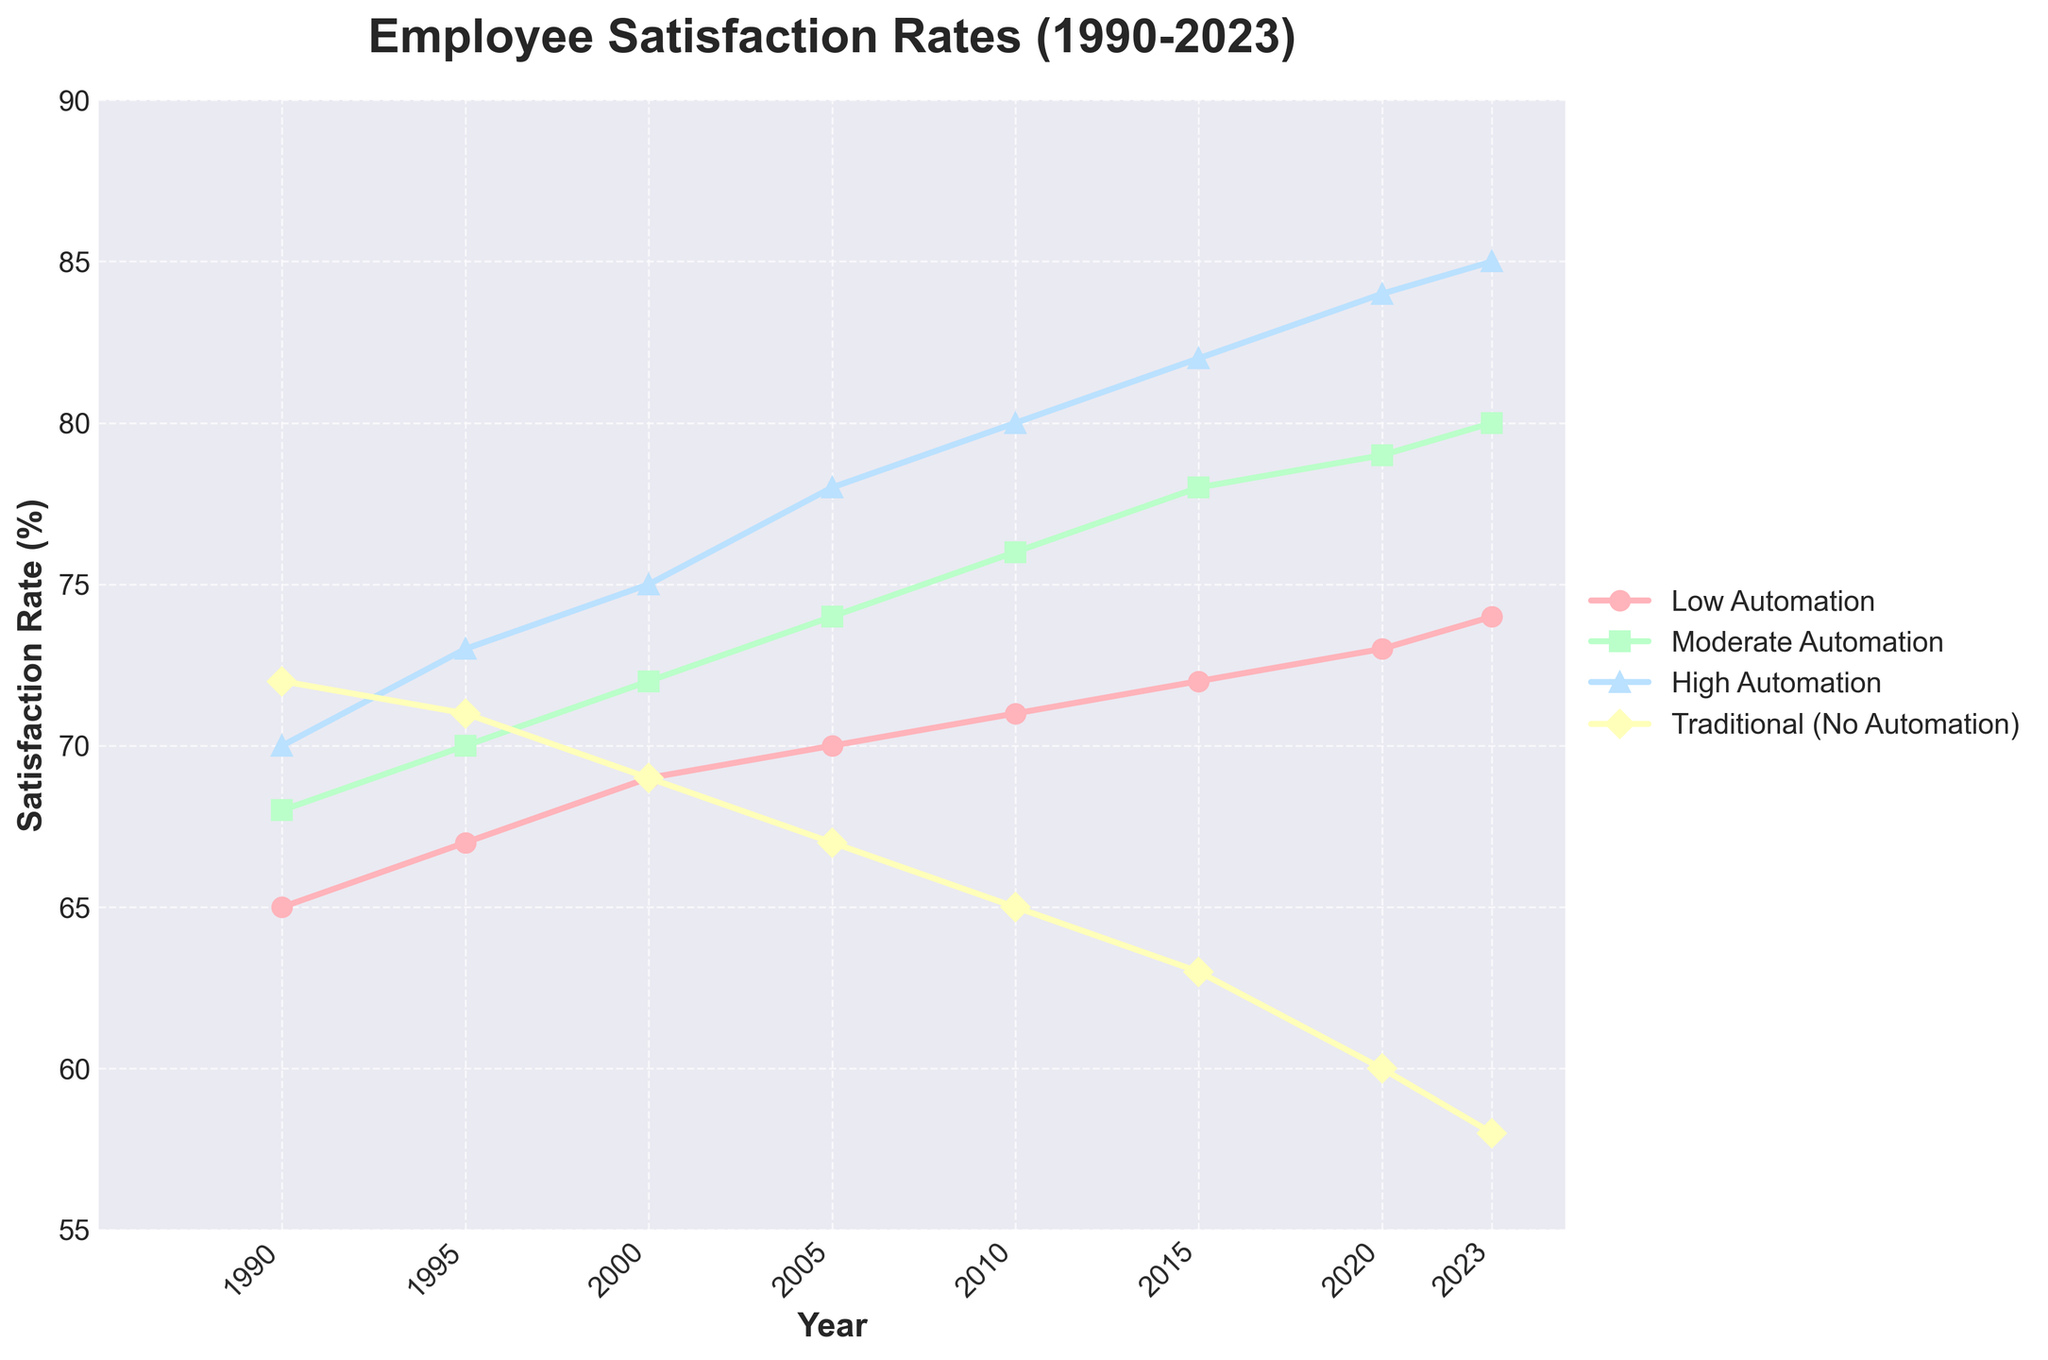What trend do we see in Employee Satisfaction Rates from 1990 to 2023 in companies with High Automation? We need to observe the line representing High Automation (colored blue) on the chart from the years 1990 to 2023. The satisfaction rate rises from 70% in 1990 to 85% in 2023. Therefore, the trend is an overall increase in satisfaction rates.
Answer: Increasing How does the satisfaction rate of Traditional companies in 2020 compare to companies with Moderate Automation in 2020? Look at the 2020 values: Traditional companies have a satisfaction rate of 60%, whereas companies with Moderate Automation have a satisfaction rate of 79%. Therefore, the satisfaction rate of Moderate Automation is higher than that of Traditional companies.
Answer: Moderate Automation is higher What is the difference in satisfaction rate between Low Automation and High Automation in 2010? Check the 2010 values: Low Automation has a satisfaction rate of 71%, and High Automation has a satisfaction rate of 80%. Subtract 71% from 80% to find the difference.
Answer: 9% By how much did the satisfaction rate increase in companies with Low Automation from 1990 to 2023? The satisfaction rate for Low Automation in 1990 is 65%, and in 2023 it is 74%. Subtract the 1990 value from the 2023 value (74% - 65%).
Answer: 9% Which category had the highest satisfaction rate in 2000? Look at the values for the year 2000 across all categories: Low Automation (69%), Moderate Automation (72%), High Automation (75%), Traditional (69%). High Automation has the highest satisfaction rate.
Answer: High Automation Compare the trends of satisfaction rates in companies with Low Automation and Traditional (No Automation) from 1990 to 2023. What can you infer? Observe the lines representing Low Automation (red) and Traditional (yellow) from 1990 to 2023. Both lines represent increasing and decreasing trends. Low Automation shows an increasing trend from 65% to 74%, while Traditional shows a decreasing trend from 72% to 58%.
Answer: Low increases, Traditional decreases What is the average satisfaction rate of companies with Moderate Automation over the period from 1990 to 2023? Sum the satisfaction rates for Moderate Automation for all years (68 + 70 + 72 + 74 + 76 + 78 + 79 + 80), then divide by the number of years considered (8). (68 + 70 + 72 + 74 + 76 + 78 + 79 + 80) / 8 = 597 / 8.
Answer: 74.625% Between which consecutive years did High Automation see the highest increase in satisfaction rate, and what was the increase? Observe the difference in satisfaction rates between consecutive years for High Automation. The differences between the years are: 
1995-1990: 3%
2000-1995: 2%
2005-2000: 3%
2010-2005: 2%
2015-2010: 2%
2020-2015: 2%
2023-2020: 1%
The highest increase, 3%, occurred between 1990-1995 and 2005-2000.
Answer: 1990-1995 and 2005-2000, 3% How does the rate of change in satisfaction rates from 1990 to 2023 in companies with High Automation compare to that of Low Automation? For companies with High Automation, the satisfaction rate changed from 70% in 1990 to 85% in 2023, an increase of 15%. For Low Automation, it changed from 65% in 1990 to 74% in 2023, an increase of 9%.
Answer: High Automation increased more What is the primary visual characteristic of the Traditional (No Automation) satisfaction rate line on the graph from 1990 to 2023? The Traditional (No Automation) line, colored yellow, shows a steady decline from 72% in 1990 to 58% in 2023. The downward trend visually stands out.
Answer: Steady decline 